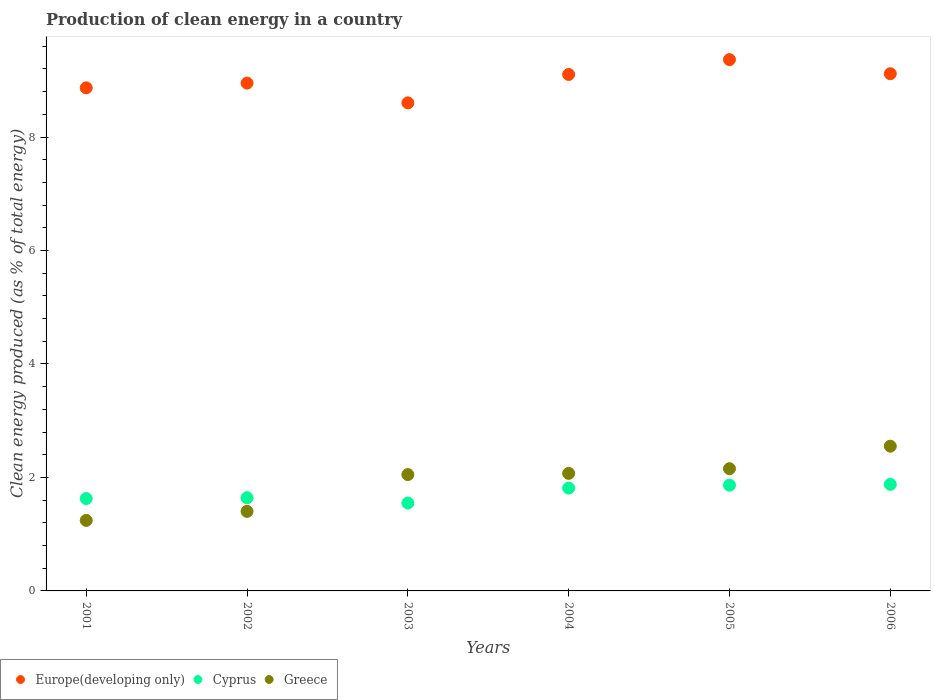How many different coloured dotlines are there?
Ensure brevity in your answer.  3. Is the number of dotlines equal to the number of legend labels?
Provide a short and direct response. Yes. What is the percentage of clean energy produced in Greece in 2003?
Your response must be concise. 2.05. Across all years, what is the maximum percentage of clean energy produced in Greece?
Make the answer very short. 2.55. Across all years, what is the minimum percentage of clean energy produced in Europe(developing only)?
Offer a very short reply. 8.6. In which year was the percentage of clean energy produced in Greece maximum?
Your answer should be compact. 2006. What is the total percentage of clean energy produced in Greece in the graph?
Provide a succinct answer. 11.47. What is the difference between the percentage of clean energy produced in Greece in 2002 and that in 2003?
Offer a very short reply. -0.65. What is the difference between the percentage of clean energy produced in Europe(developing only) in 2002 and the percentage of clean energy produced in Greece in 2005?
Your response must be concise. 6.8. What is the average percentage of clean energy produced in Greece per year?
Keep it short and to the point. 1.91. In the year 2005, what is the difference between the percentage of clean energy produced in Cyprus and percentage of clean energy produced in Europe(developing only)?
Keep it short and to the point. -7.5. What is the ratio of the percentage of clean energy produced in Cyprus in 2001 to that in 2004?
Your response must be concise. 0.9. Is the difference between the percentage of clean energy produced in Cyprus in 2005 and 2006 greater than the difference between the percentage of clean energy produced in Europe(developing only) in 2005 and 2006?
Provide a succinct answer. No. What is the difference between the highest and the second highest percentage of clean energy produced in Greece?
Give a very brief answer. 0.4. What is the difference between the highest and the lowest percentage of clean energy produced in Europe(developing only)?
Make the answer very short. 0.76. In how many years, is the percentage of clean energy produced in Cyprus greater than the average percentage of clean energy produced in Cyprus taken over all years?
Your response must be concise. 3. Is it the case that in every year, the sum of the percentage of clean energy produced in Greece and percentage of clean energy produced in Europe(developing only)  is greater than the percentage of clean energy produced in Cyprus?
Give a very brief answer. Yes. Is the percentage of clean energy produced in Greece strictly greater than the percentage of clean energy produced in Cyprus over the years?
Provide a succinct answer. No. How many dotlines are there?
Offer a very short reply. 3. Does the graph contain any zero values?
Offer a terse response. No. Does the graph contain grids?
Keep it short and to the point. No. How are the legend labels stacked?
Give a very brief answer. Horizontal. What is the title of the graph?
Make the answer very short. Production of clean energy in a country. Does "St. Vincent and the Grenadines" appear as one of the legend labels in the graph?
Keep it short and to the point. No. What is the label or title of the X-axis?
Offer a very short reply. Years. What is the label or title of the Y-axis?
Provide a succinct answer. Clean energy produced (as % of total energy). What is the Clean energy produced (as % of total energy) in Europe(developing only) in 2001?
Make the answer very short. 8.87. What is the Clean energy produced (as % of total energy) of Cyprus in 2001?
Provide a short and direct response. 1.63. What is the Clean energy produced (as % of total energy) of Greece in 2001?
Offer a very short reply. 1.24. What is the Clean energy produced (as % of total energy) of Europe(developing only) in 2002?
Your answer should be compact. 8.95. What is the Clean energy produced (as % of total energy) of Cyprus in 2002?
Your response must be concise. 1.64. What is the Clean energy produced (as % of total energy) in Greece in 2002?
Your answer should be compact. 1.4. What is the Clean energy produced (as % of total energy) in Europe(developing only) in 2003?
Offer a terse response. 8.6. What is the Clean energy produced (as % of total energy) of Cyprus in 2003?
Offer a very short reply. 1.55. What is the Clean energy produced (as % of total energy) of Greece in 2003?
Provide a short and direct response. 2.05. What is the Clean energy produced (as % of total energy) in Europe(developing only) in 2004?
Provide a short and direct response. 9.1. What is the Clean energy produced (as % of total energy) in Cyprus in 2004?
Make the answer very short. 1.81. What is the Clean energy produced (as % of total energy) in Greece in 2004?
Keep it short and to the point. 2.07. What is the Clean energy produced (as % of total energy) of Europe(developing only) in 2005?
Your answer should be very brief. 9.36. What is the Clean energy produced (as % of total energy) of Cyprus in 2005?
Make the answer very short. 1.86. What is the Clean energy produced (as % of total energy) in Greece in 2005?
Ensure brevity in your answer.  2.15. What is the Clean energy produced (as % of total energy) in Europe(developing only) in 2006?
Your answer should be compact. 9.12. What is the Clean energy produced (as % of total energy) of Cyprus in 2006?
Your answer should be compact. 1.88. What is the Clean energy produced (as % of total energy) of Greece in 2006?
Make the answer very short. 2.55. Across all years, what is the maximum Clean energy produced (as % of total energy) of Europe(developing only)?
Offer a very short reply. 9.36. Across all years, what is the maximum Clean energy produced (as % of total energy) in Cyprus?
Keep it short and to the point. 1.88. Across all years, what is the maximum Clean energy produced (as % of total energy) of Greece?
Give a very brief answer. 2.55. Across all years, what is the minimum Clean energy produced (as % of total energy) in Europe(developing only)?
Provide a succinct answer. 8.6. Across all years, what is the minimum Clean energy produced (as % of total energy) in Cyprus?
Provide a short and direct response. 1.55. Across all years, what is the minimum Clean energy produced (as % of total energy) of Greece?
Ensure brevity in your answer.  1.24. What is the total Clean energy produced (as % of total energy) of Europe(developing only) in the graph?
Keep it short and to the point. 54. What is the total Clean energy produced (as % of total energy) of Cyprus in the graph?
Offer a very short reply. 10.37. What is the total Clean energy produced (as % of total energy) of Greece in the graph?
Your answer should be very brief. 11.47. What is the difference between the Clean energy produced (as % of total energy) of Europe(developing only) in 2001 and that in 2002?
Keep it short and to the point. -0.08. What is the difference between the Clean energy produced (as % of total energy) in Cyprus in 2001 and that in 2002?
Provide a succinct answer. -0.01. What is the difference between the Clean energy produced (as % of total energy) of Greece in 2001 and that in 2002?
Your answer should be compact. -0.16. What is the difference between the Clean energy produced (as % of total energy) of Europe(developing only) in 2001 and that in 2003?
Your response must be concise. 0.26. What is the difference between the Clean energy produced (as % of total energy) of Cyprus in 2001 and that in 2003?
Provide a short and direct response. 0.08. What is the difference between the Clean energy produced (as % of total energy) in Greece in 2001 and that in 2003?
Ensure brevity in your answer.  -0.81. What is the difference between the Clean energy produced (as % of total energy) of Europe(developing only) in 2001 and that in 2004?
Offer a very short reply. -0.24. What is the difference between the Clean energy produced (as % of total energy) of Cyprus in 2001 and that in 2004?
Your answer should be compact. -0.19. What is the difference between the Clean energy produced (as % of total energy) in Greece in 2001 and that in 2004?
Your answer should be very brief. -0.83. What is the difference between the Clean energy produced (as % of total energy) in Europe(developing only) in 2001 and that in 2005?
Offer a terse response. -0.5. What is the difference between the Clean energy produced (as % of total energy) of Cyprus in 2001 and that in 2005?
Your answer should be very brief. -0.24. What is the difference between the Clean energy produced (as % of total energy) of Greece in 2001 and that in 2005?
Your response must be concise. -0.91. What is the difference between the Clean energy produced (as % of total energy) in Europe(developing only) in 2001 and that in 2006?
Your answer should be very brief. -0.25. What is the difference between the Clean energy produced (as % of total energy) in Cyprus in 2001 and that in 2006?
Offer a terse response. -0.25. What is the difference between the Clean energy produced (as % of total energy) of Greece in 2001 and that in 2006?
Make the answer very short. -1.31. What is the difference between the Clean energy produced (as % of total energy) of Europe(developing only) in 2002 and that in 2003?
Give a very brief answer. 0.35. What is the difference between the Clean energy produced (as % of total energy) of Cyprus in 2002 and that in 2003?
Provide a succinct answer. 0.09. What is the difference between the Clean energy produced (as % of total energy) in Greece in 2002 and that in 2003?
Provide a short and direct response. -0.65. What is the difference between the Clean energy produced (as % of total energy) of Europe(developing only) in 2002 and that in 2004?
Your answer should be very brief. -0.15. What is the difference between the Clean energy produced (as % of total energy) in Cyprus in 2002 and that in 2004?
Offer a terse response. -0.17. What is the difference between the Clean energy produced (as % of total energy) in Greece in 2002 and that in 2004?
Ensure brevity in your answer.  -0.67. What is the difference between the Clean energy produced (as % of total energy) in Europe(developing only) in 2002 and that in 2005?
Your answer should be compact. -0.41. What is the difference between the Clean energy produced (as % of total energy) in Cyprus in 2002 and that in 2005?
Make the answer very short. -0.22. What is the difference between the Clean energy produced (as % of total energy) in Greece in 2002 and that in 2005?
Offer a terse response. -0.75. What is the difference between the Clean energy produced (as % of total energy) of Europe(developing only) in 2002 and that in 2006?
Give a very brief answer. -0.17. What is the difference between the Clean energy produced (as % of total energy) of Cyprus in 2002 and that in 2006?
Your answer should be very brief. -0.24. What is the difference between the Clean energy produced (as % of total energy) of Greece in 2002 and that in 2006?
Provide a succinct answer. -1.15. What is the difference between the Clean energy produced (as % of total energy) in Europe(developing only) in 2003 and that in 2004?
Provide a short and direct response. -0.5. What is the difference between the Clean energy produced (as % of total energy) in Cyprus in 2003 and that in 2004?
Your answer should be very brief. -0.26. What is the difference between the Clean energy produced (as % of total energy) in Greece in 2003 and that in 2004?
Keep it short and to the point. -0.02. What is the difference between the Clean energy produced (as % of total energy) of Europe(developing only) in 2003 and that in 2005?
Offer a very short reply. -0.76. What is the difference between the Clean energy produced (as % of total energy) of Cyprus in 2003 and that in 2005?
Your answer should be compact. -0.31. What is the difference between the Clean energy produced (as % of total energy) of Greece in 2003 and that in 2005?
Give a very brief answer. -0.1. What is the difference between the Clean energy produced (as % of total energy) of Europe(developing only) in 2003 and that in 2006?
Ensure brevity in your answer.  -0.51. What is the difference between the Clean energy produced (as % of total energy) of Cyprus in 2003 and that in 2006?
Provide a short and direct response. -0.33. What is the difference between the Clean energy produced (as % of total energy) in Greece in 2003 and that in 2006?
Offer a terse response. -0.5. What is the difference between the Clean energy produced (as % of total energy) in Europe(developing only) in 2004 and that in 2005?
Your answer should be compact. -0.26. What is the difference between the Clean energy produced (as % of total energy) of Cyprus in 2004 and that in 2005?
Keep it short and to the point. -0.05. What is the difference between the Clean energy produced (as % of total energy) in Greece in 2004 and that in 2005?
Provide a short and direct response. -0.08. What is the difference between the Clean energy produced (as % of total energy) in Europe(developing only) in 2004 and that in 2006?
Keep it short and to the point. -0.01. What is the difference between the Clean energy produced (as % of total energy) in Cyprus in 2004 and that in 2006?
Your answer should be very brief. -0.07. What is the difference between the Clean energy produced (as % of total energy) of Greece in 2004 and that in 2006?
Your answer should be very brief. -0.48. What is the difference between the Clean energy produced (as % of total energy) in Europe(developing only) in 2005 and that in 2006?
Provide a short and direct response. 0.25. What is the difference between the Clean energy produced (as % of total energy) of Cyprus in 2005 and that in 2006?
Give a very brief answer. -0.01. What is the difference between the Clean energy produced (as % of total energy) of Greece in 2005 and that in 2006?
Offer a terse response. -0.4. What is the difference between the Clean energy produced (as % of total energy) of Europe(developing only) in 2001 and the Clean energy produced (as % of total energy) of Cyprus in 2002?
Offer a terse response. 7.22. What is the difference between the Clean energy produced (as % of total energy) of Europe(developing only) in 2001 and the Clean energy produced (as % of total energy) of Greece in 2002?
Offer a terse response. 7.47. What is the difference between the Clean energy produced (as % of total energy) of Cyprus in 2001 and the Clean energy produced (as % of total energy) of Greece in 2002?
Your answer should be very brief. 0.23. What is the difference between the Clean energy produced (as % of total energy) of Europe(developing only) in 2001 and the Clean energy produced (as % of total energy) of Cyprus in 2003?
Provide a short and direct response. 7.32. What is the difference between the Clean energy produced (as % of total energy) of Europe(developing only) in 2001 and the Clean energy produced (as % of total energy) of Greece in 2003?
Offer a terse response. 6.82. What is the difference between the Clean energy produced (as % of total energy) of Cyprus in 2001 and the Clean energy produced (as % of total energy) of Greece in 2003?
Your response must be concise. -0.42. What is the difference between the Clean energy produced (as % of total energy) of Europe(developing only) in 2001 and the Clean energy produced (as % of total energy) of Cyprus in 2004?
Your answer should be compact. 7.05. What is the difference between the Clean energy produced (as % of total energy) of Europe(developing only) in 2001 and the Clean energy produced (as % of total energy) of Greece in 2004?
Ensure brevity in your answer.  6.8. What is the difference between the Clean energy produced (as % of total energy) of Cyprus in 2001 and the Clean energy produced (as % of total energy) of Greece in 2004?
Your response must be concise. -0.44. What is the difference between the Clean energy produced (as % of total energy) in Europe(developing only) in 2001 and the Clean energy produced (as % of total energy) in Cyprus in 2005?
Provide a succinct answer. 7. What is the difference between the Clean energy produced (as % of total energy) of Europe(developing only) in 2001 and the Clean energy produced (as % of total energy) of Greece in 2005?
Keep it short and to the point. 6.71. What is the difference between the Clean energy produced (as % of total energy) of Cyprus in 2001 and the Clean energy produced (as % of total energy) of Greece in 2005?
Make the answer very short. -0.53. What is the difference between the Clean energy produced (as % of total energy) of Europe(developing only) in 2001 and the Clean energy produced (as % of total energy) of Cyprus in 2006?
Provide a succinct answer. 6.99. What is the difference between the Clean energy produced (as % of total energy) of Europe(developing only) in 2001 and the Clean energy produced (as % of total energy) of Greece in 2006?
Keep it short and to the point. 6.32. What is the difference between the Clean energy produced (as % of total energy) in Cyprus in 2001 and the Clean energy produced (as % of total energy) in Greece in 2006?
Provide a succinct answer. -0.92. What is the difference between the Clean energy produced (as % of total energy) in Europe(developing only) in 2002 and the Clean energy produced (as % of total energy) in Cyprus in 2003?
Ensure brevity in your answer.  7.4. What is the difference between the Clean energy produced (as % of total energy) in Europe(developing only) in 2002 and the Clean energy produced (as % of total energy) in Greece in 2003?
Your answer should be compact. 6.9. What is the difference between the Clean energy produced (as % of total energy) in Cyprus in 2002 and the Clean energy produced (as % of total energy) in Greece in 2003?
Give a very brief answer. -0.41. What is the difference between the Clean energy produced (as % of total energy) in Europe(developing only) in 2002 and the Clean energy produced (as % of total energy) in Cyprus in 2004?
Provide a short and direct response. 7.14. What is the difference between the Clean energy produced (as % of total energy) of Europe(developing only) in 2002 and the Clean energy produced (as % of total energy) of Greece in 2004?
Your answer should be very brief. 6.88. What is the difference between the Clean energy produced (as % of total energy) in Cyprus in 2002 and the Clean energy produced (as % of total energy) in Greece in 2004?
Provide a short and direct response. -0.43. What is the difference between the Clean energy produced (as % of total energy) in Europe(developing only) in 2002 and the Clean energy produced (as % of total energy) in Cyprus in 2005?
Offer a terse response. 7.09. What is the difference between the Clean energy produced (as % of total energy) in Europe(developing only) in 2002 and the Clean energy produced (as % of total energy) in Greece in 2005?
Offer a terse response. 6.8. What is the difference between the Clean energy produced (as % of total energy) of Cyprus in 2002 and the Clean energy produced (as % of total energy) of Greece in 2005?
Offer a very short reply. -0.51. What is the difference between the Clean energy produced (as % of total energy) of Europe(developing only) in 2002 and the Clean energy produced (as % of total energy) of Cyprus in 2006?
Your response must be concise. 7.07. What is the difference between the Clean energy produced (as % of total energy) in Europe(developing only) in 2002 and the Clean energy produced (as % of total energy) in Greece in 2006?
Your response must be concise. 6.4. What is the difference between the Clean energy produced (as % of total energy) of Cyprus in 2002 and the Clean energy produced (as % of total energy) of Greece in 2006?
Your answer should be very brief. -0.91. What is the difference between the Clean energy produced (as % of total energy) in Europe(developing only) in 2003 and the Clean energy produced (as % of total energy) in Cyprus in 2004?
Ensure brevity in your answer.  6.79. What is the difference between the Clean energy produced (as % of total energy) in Europe(developing only) in 2003 and the Clean energy produced (as % of total energy) in Greece in 2004?
Provide a short and direct response. 6.53. What is the difference between the Clean energy produced (as % of total energy) of Cyprus in 2003 and the Clean energy produced (as % of total energy) of Greece in 2004?
Keep it short and to the point. -0.52. What is the difference between the Clean energy produced (as % of total energy) of Europe(developing only) in 2003 and the Clean energy produced (as % of total energy) of Cyprus in 2005?
Ensure brevity in your answer.  6.74. What is the difference between the Clean energy produced (as % of total energy) of Europe(developing only) in 2003 and the Clean energy produced (as % of total energy) of Greece in 2005?
Your response must be concise. 6.45. What is the difference between the Clean energy produced (as % of total energy) in Cyprus in 2003 and the Clean energy produced (as % of total energy) in Greece in 2005?
Provide a short and direct response. -0.6. What is the difference between the Clean energy produced (as % of total energy) in Europe(developing only) in 2003 and the Clean energy produced (as % of total energy) in Cyprus in 2006?
Provide a succinct answer. 6.72. What is the difference between the Clean energy produced (as % of total energy) in Europe(developing only) in 2003 and the Clean energy produced (as % of total energy) in Greece in 2006?
Your answer should be very brief. 6.05. What is the difference between the Clean energy produced (as % of total energy) in Cyprus in 2003 and the Clean energy produced (as % of total energy) in Greece in 2006?
Ensure brevity in your answer.  -1. What is the difference between the Clean energy produced (as % of total energy) in Europe(developing only) in 2004 and the Clean energy produced (as % of total energy) in Cyprus in 2005?
Provide a short and direct response. 7.24. What is the difference between the Clean energy produced (as % of total energy) in Europe(developing only) in 2004 and the Clean energy produced (as % of total energy) in Greece in 2005?
Provide a succinct answer. 6.95. What is the difference between the Clean energy produced (as % of total energy) of Cyprus in 2004 and the Clean energy produced (as % of total energy) of Greece in 2005?
Make the answer very short. -0.34. What is the difference between the Clean energy produced (as % of total energy) of Europe(developing only) in 2004 and the Clean energy produced (as % of total energy) of Cyprus in 2006?
Provide a short and direct response. 7.22. What is the difference between the Clean energy produced (as % of total energy) of Europe(developing only) in 2004 and the Clean energy produced (as % of total energy) of Greece in 2006?
Your response must be concise. 6.55. What is the difference between the Clean energy produced (as % of total energy) of Cyprus in 2004 and the Clean energy produced (as % of total energy) of Greece in 2006?
Provide a succinct answer. -0.74. What is the difference between the Clean energy produced (as % of total energy) of Europe(developing only) in 2005 and the Clean energy produced (as % of total energy) of Cyprus in 2006?
Ensure brevity in your answer.  7.49. What is the difference between the Clean energy produced (as % of total energy) in Europe(developing only) in 2005 and the Clean energy produced (as % of total energy) in Greece in 2006?
Your response must be concise. 6.81. What is the difference between the Clean energy produced (as % of total energy) in Cyprus in 2005 and the Clean energy produced (as % of total energy) in Greece in 2006?
Provide a succinct answer. -0.69. What is the average Clean energy produced (as % of total energy) of Europe(developing only) per year?
Offer a very short reply. 9. What is the average Clean energy produced (as % of total energy) of Cyprus per year?
Your answer should be compact. 1.73. What is the average Clean energy produced (as % of total energy) in Greece per year?
Provide a short and direct response. 1.91. In the year 2001, what is the difference between the Clean energy produced (as % of total energy) in Europe(developing only) and Clean energy produced (as % of total energy) in Cyprus?
Your response must be concise. 7.24. In the year 2001, what is the difference between the Clean energy produced (as % of total energy) in Europe(developing only) and Clean energy produced (as % of total energy) in Greece?
Keep it short and to the point. 7.62. In the year 2001, what is the difference between the Clean energy produced (as % of total energy) of Cyprus and Clean energy produced (as % of total energy) of Greece?
Offer a terse response. 0.38. In the year 2002, what is the difference between the Clean energy produced (as % of total energy) in Europe(developing only) and Clean energy produced (as % of total energy) in Cyprus?
Your response must be concise. 7.31. In the year 2002, what is the difference between the Clean energy produced (as % of total energy) in Europe(developing only) and Clean energy produced (as % of total energy) in Greece?
Offer a very short reply. 7.55. In the year 2002, what is the difference between the Clean energy produced (as % of total energy) of Cyprus and Clean energy produced (as % of total energy) of Greece?
Ensure brevity in your answer.  0.24. In the year 2003, what is the difference between the Clean energy produced (as % of total energy) in Europe(developing only) and Clean energy produced (as % of total energy) in Cyprus?
Your answer should be very brief. 7.05. In the year 2003, what is the difference between the Clean energy produced (as % of total energy) of Europe(developing only) and Clean energy produced (as % of total energy) of Greece?
Your response must be concise. 6.55. In the year 2003, what is the difference between the Clean energy produced (as % of total energy) of Cyprus and Clean energy produced (as % of total energy) of Greece?
Provide a short and direct response. -0.5. In the year 2004, what is the difference between the Clean energy produced (as % of total energy) of Europe(developing only) and Clean energy produced (as % of total energy) of Cyprus?
Ensure brevity in your answer.  7.29. In the year 2004, what is the difference between the Clean energy produced (as % of total energy) of Europe(developing only) and Clean energy produced (as % of total energy) of Greece?
Ensure brevity in your answer.  7.03. In the year 2004, what is the difference between the Clean energy produced (as % of total energy) of Cyprus and Clean energy produced (as % of total energy) of Greece?
Provide a short and direct response. -0.26. In the year 2005, what is the difference between the Clean energy produced (as % of total energy) in Europe(developing only) and Clean energy produced (as % of total energy) in Cyprus?
Your response must be concise. 7.5. In the year 2005, what is the difference between the Clean energy produced (as % of total energy) in Europe(developing only) and Clean energy produced (as % of total energy) in Greece?
Make the answer very short. 7.21. In the year 2005, what is the difference between the Clean energy produced (as % of total energy) of Cyprus and Clean energy produced (as % of total energy) of Greece?
Offer a very short reply. -0.29. In the year 2006, what is the difference between the Clean energy produced (as % of total energy) of Europe(developing only) and Clean energy produced (as % of total energy) of Cyprus?
Provide a succinct answer. 7.24. In the year 2006, what is the difference between the Clean energy produced (as % of total energy) of Europe(developing only) and Clean energy produced (as % of total energy) of Greece?
Give a very brief answer. 6.57. In the year 2006, what is the difference between the Clean energy produced (as % of total energy) in Cyprus and Clean energy produced (as % of total energy) in Greece?
Provide a short and direct response. -0.67. What is the ratio of the Clean energy produced (as % of total energy) of Cyprus in 2001 to that in 2002?
Keep it short and to the point. 0.99. What is the ratio of the Clean energy produced (as % of total energy) of Greece in 2001 to that in 2002?
Provide a short and direct response. 0.89. What is the ratio of the Clean energy produced (as % of total energy) of Europe(developing only) in 2001 to that in 2003?
Make the answer very short. 1.03. What is the ratio of the Clean energy produced (as % of total energy) in Cyprus in 2001 to that in 2003?
Provide a short and direct response. 1.05. What is the ratio of the Clean energy produced (as % of total energy) in Greece in 2001 to that in 2003?
Ensure brevity in your answer.  0.61. What is the ratio of the Clean energy produced (as % of total energy) in Europe(developing only) in 2001 to that in 2004?
Your answer should be very brief. 0.97. What is the ratio of the Clean energy produced (as % of total energy) of Cyprus in 2001 to that in 2004?
Offer a very short reply. 0.9. What is the ratio of the Clean energy produced (as % of total energy) in Greece in 2001 to that in 2004?
Give a very brief answer. 0.6. What is the ratio of the Clean energy produced (as % of total energy) in Europe(developing only) in 2001 to that in 2005?
Provide a succinct answer. 0.95. What is the ratio of the Clean energy produced (as % of total energy) in Cyprus in 2001 to that in 2005?
Provide a short and direct response. 0.87. What is the ratio of the Clean energy produced (as % of total energy) in Greece in 2001 to that in 2005?
Make the answer very short. 0.58. What is the ratio of the Clean energy produced (as % of total energy) in Europe(developing only) in 2001 to that in 2006?
Give a very brief answer. 0.97. What is the ratio of the Clean energy produced (as % of total energy) in Cyprus in 2001 to that in 2006?
Provide a succinct answer. 0.87. What is the ratio of the Clean energy produced (as % of total energy) of Greece in 2001 to that in 2006?
Make the answer very short. 0.49. What is the ratio of the Clean energy produced (as % of total energy) of Europe(developing only) in 2002 to that in 2003?
Your response must be concise. 1.04. What is the ratio of the Clean energy produced (as % of total energy) in Cyprus in 2002 to that in 2003?
Your answer should be very brief. 1.06. What is the ratio of the Clean energy produced (as % of total energy) in Greece in 2002 to that in 2003?
Offer a terse response. 0.68. What is the ratio of the Clean energy produced (as % of total energy) in Europe(developing only) in 2002 to that in 2004?
Offer a very short reply. 0.98. What is the ratio of the Clean energy produced (as % of total energy) of Cyprus in 2002 to that in 2004?
Your answer should be compact. 0.91. What is the ratio of the Clean energy produced (as % of total energy) of Greece in 2002 to that in 2004?
Make the answer very short. 0.68. What is the ratio of the Clean energy produced (as % of total energy) in Europe(developing only) in 2002 to that in 2005?
Give a very brief answer. 0.96. What is the ratio of the Clean energy produced (as % of total energy) of Cyprus in 2002 to that in 2005?
Ensure brevity in your answer.  0.88. What is the ratio of the Clean energy produced (as % of total energy) of Greece in 2002 to that in 2005?
Offer a very short reply. 0.65. What is the ratio of the Clean energy produced (as % of total energy) of Europe(developing only) in 2002 to that in 2006?
Keep it short and to the point. 0.98. What is the ratio of the Clean energy produced (as % of total energy) in Cyprus in 2002 to that in 2006?
Provide a succinct answer. 0.87. What is the ratio of the Clean energy produced (as % of total energy) of Greece in 2002 to that in 2006?
Offer a very short reply. 0.55. What is the ratio of the Clean energy produced (as % of total energy) of Europe(developing only) in 2003 to that in 2004?
Your response must be concise. 0.94. What is the ratio of the Clean energy produced (as % of total energy) of Cyprus in 2003 to that in 2004?
Offer a terse response. 0.85. What is the ratio of the Clean energy produced (as % of total energy) in Greece in 2003 to that in 2004?
Make the answer very short. 0.99. What is the ratio of the Clean energy produced (as % of total energy) of Europe(developing only) in 2003 to that in 2005?
Make the answer very short. 0.92. What is the ratio of the Clean energy produced (as % of total energy) in Cyprus in 2003 to that in 2005?
Your answer should be compact. 0.83. What is the ratio of the Clean energy produced (as % of total energy) of Greece in 2003 to that in 2005?
Give a very brief answer. 0.95. What is the ratio of the Clean energy produced (as % of total energy) of Europe(developing only) in 2003 to that in 2006?
Offer a very short reply. 0.94. What is the ratio of the Clean energy produced (as % of total energy) in Cyprus in 2003 to that in 2006?
Ensure brevity in your answer.  0.82. What is the ratio of the Clean energy produced (as % of total energy) of Greece in 2003 to that in 2006?
Offer a terse response. 0.8. What is the ratio of the Clean energy produced (as % of total energy) of Cyprus in 2004 to that in 2005?
Give a very brief answer. 0.97. What is the ratio of the Clean energy produced (as % of total energy) of Greece in 2004 to that in 2005?
Provide a succinct answer. 0.96. What is the ratio of the Clean energy produced (as % of total energy) in Europe(developing only) in 2004 to that in 2006?
Your answer should be very brief. 1. What is the ratio of the Clean energy produced (as % of total energy) in Cyprus in 2004 to that in 2006?
Make the answer very short. 0.97. What is the ratio of the Clean energy produced (as % of total energy) of Greece in 2004 to that in 2006?
Your answer should be very brief. 0.81. What is the ratio of the Clean energy produced (as % of total energy) in Europe(developing only) in 2005 to that in 2006?
Provide a succinct answer. 1.03. What is the ratio of the Clean energy produced (as % of total energy) of Cyprus in 2005 to that in 2006?
Provide a short and direct response. 0.99. What is the ratio of the Clean energy produced (as % of total energy) in Greece in 2005 to that in 2006?
Provide a short and direct response. 0.84. What is the difference between the highest and the second highest Clean energy produced (as % of total energy) in Europe(developing only)?
Ensure brevity in your answer.  0.25. What is the difference between the highest and the second highest Clean energy produced (as % of total energy) of Cyprus?
Your response must be concise. 0.01. What is the difference between the highest and the second highest Clean energy produced (as % of total energy) in Greece?
Provide a succinct answer. 0.4. What is the difference between the highest and the lowest Clean energy produced (as % of total energy) in Europe(developing only)?
Ensure brevity in your answer.  0.76. What is the difference between the highest and the lowest Clean energy produced (as % of total energy) in Cyprus?
Provide a short and direct response. 0.33. What is the difference between the highest and the lowest Clean energy produced (as % of total energy) of Greece?
Give a very brief answer. 1.31. 